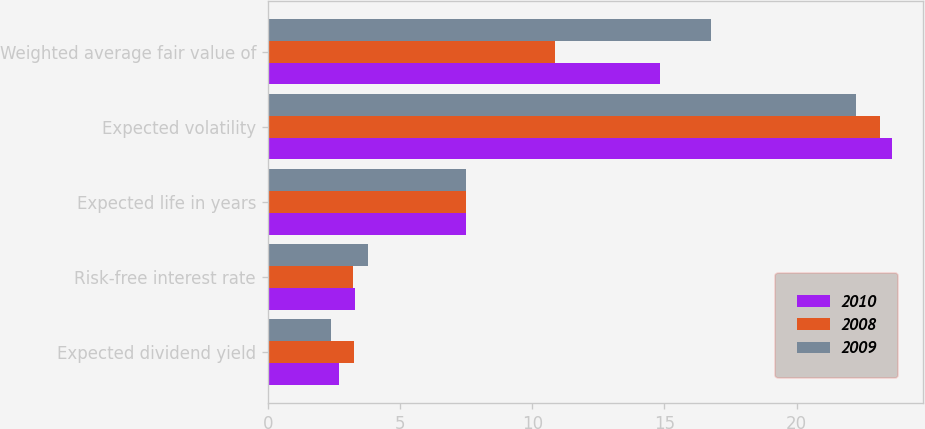<chart> <loc_0><loc_0><loc_500><loc_500><stacked_bar_chart><ecel><fcel>Expected dividend yield<fcel>Risk-free interest rate<fcel>Expected life in years<fcel>Expected volatility<fcel>Weighted average fair value of<nl><fcel>2010<fcel>2.7<fcel>3.3<fcel>7.5<fcel>23.59<fcel>14.83<nl><fcel>2008<fcel>3.25<fcel>3.22<fcel>7.5<fcel>23.16<fcel>10.86<nl><fcel>2009<fcel>2.39<fcel>3.79<fcel>7.5<fcel>22.24<fcel>16.77<nl></chart> 